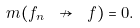Convert formula to latex. <formula><loc_0><loc_0><loc_500><loc_500>m ( f _ { n } \ \nrightarrow \ f ) = 0 .</formula> 